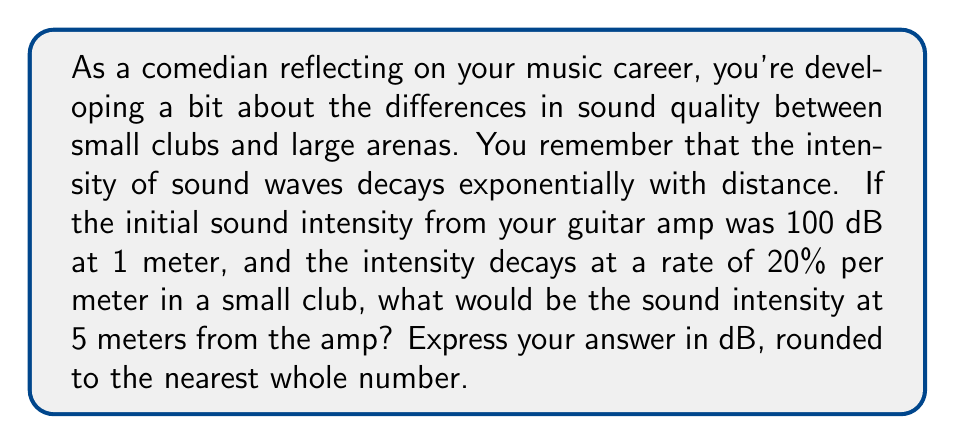Could you help me with this problem? Let's approach this step-by-step:

1) The decay of sound intensity can be modeled by the exponential function:

   $$I(x) = I_0 \cdot e^{-kx}$$

   where $I(x)$ is the intensity at distance $x$, $I_0$ is the initial intensity, and $k$ is the decay constant.

2) We're given that the intensity decays at 20% per meter. This means that after 1 meter, 80% of the intensity remains. We can use this to find $k$:

   $$e^{-k} = 0.8$$
   $$k = -\ln(0.8) \approx 0.223$$

3) Now we have our complete model:

   $$I(x) = 100 \cdot e^{-0.223x}$$

4) To find the intensity at 5 meters:

   $$I(5) = 100 \cdot e^{-0.223 \cdot 5} \approx 32.97$$

5) However, this is in linear scale. We need to convert it back to dB:

   $$dB = 10 \cdot \log_{10}(I)$$
   $$dB = 10 \cdot \log_{10}(32.97) \approx 51.18$$

6) Rounding to the nearest whole number:

   $$51 \text{ dB}$$
Answer: 51 dB 